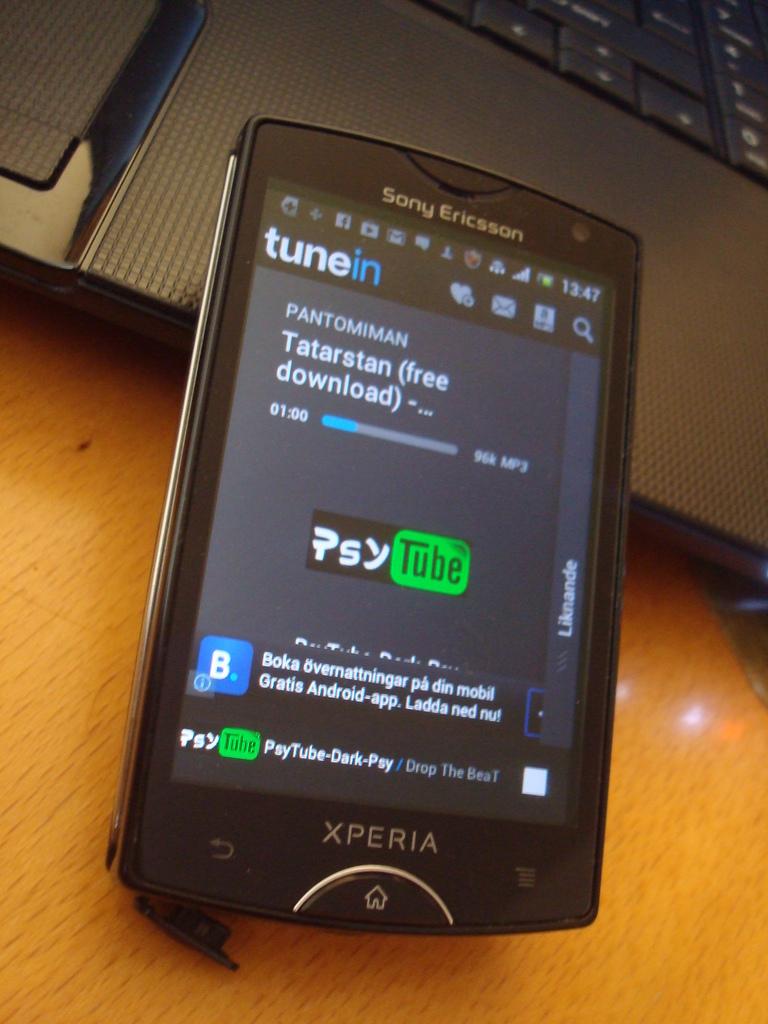What is the app being used on the phone?
Offer a terse response. Tunein. What is the name of the phone?
Offer a terse response. Sony ericsson. 